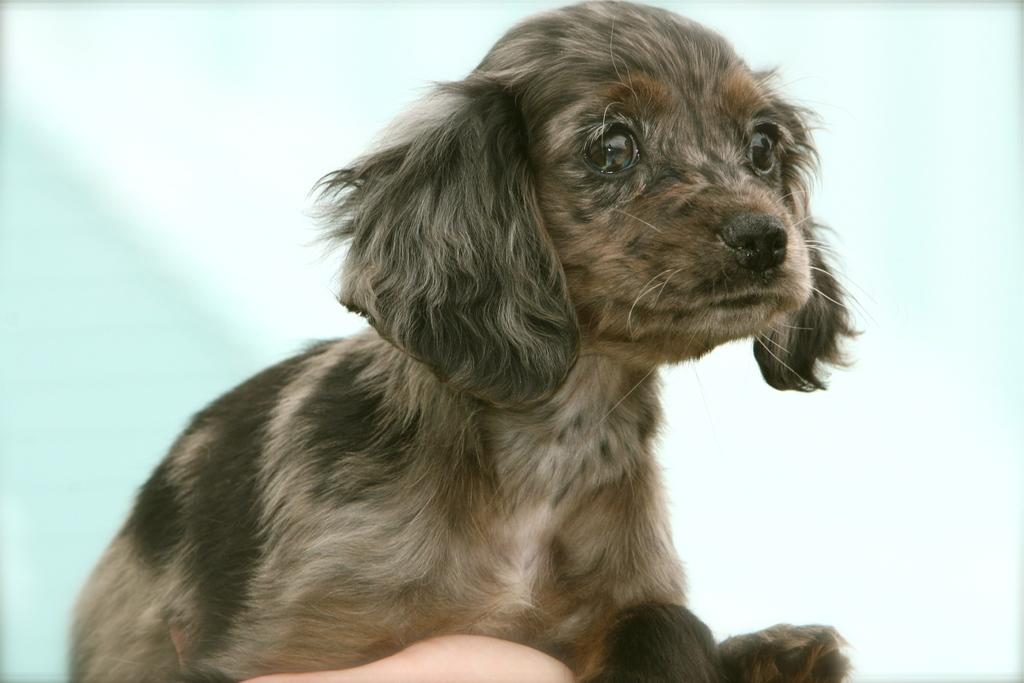What is the main subject in the center of the image? There is a puppy in the center of the image. Can you describe any other elements in the image? A person's finger is visible at the bottom of the image, and there is a wall in the background. What type of treatment is the puppy receiving in the image? There is no indication in the image that the puppy is receiving any treatment. What color are the trousers worn by the person in the image? There is no person wearing trousers in the image; only a finger is visible. Can you spot any stars in the image? There are no stars visible in the image. 